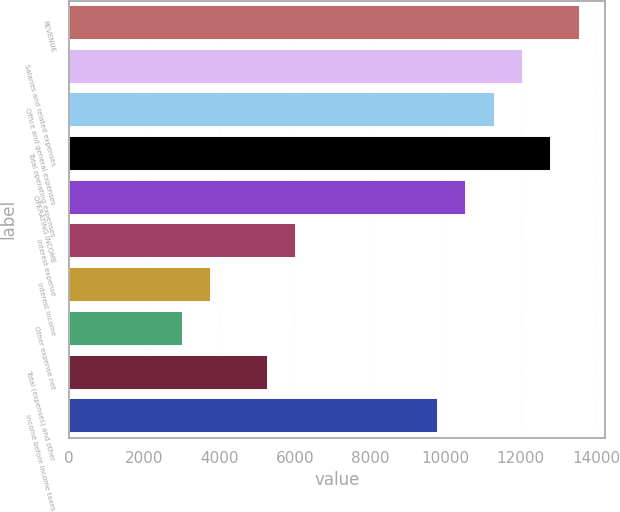Convert chart. <chart><loc_0><loc_0><loc_500><loc_500><bar_chart><fcel>REVENUE<fcel>Salaries and related expenses<fcel>Office and general expenses<fcel>Total operating expenses<fcel>OPERATING INCOME<fcel>Interest expense<fcel>Interest income<fcel>Other expense net<fcel>Total (expenses) and other<fcel>Income before income taxes<nl><fcel>13566.4<fcel>12059.1<fcel>11305.4<fcel>12812.8<fcel>10551.8<fcel>6029.74<fcel>3768.73<fcel>3015.06<fcel>5276.07<fcel>9798.09<nl></chart> 